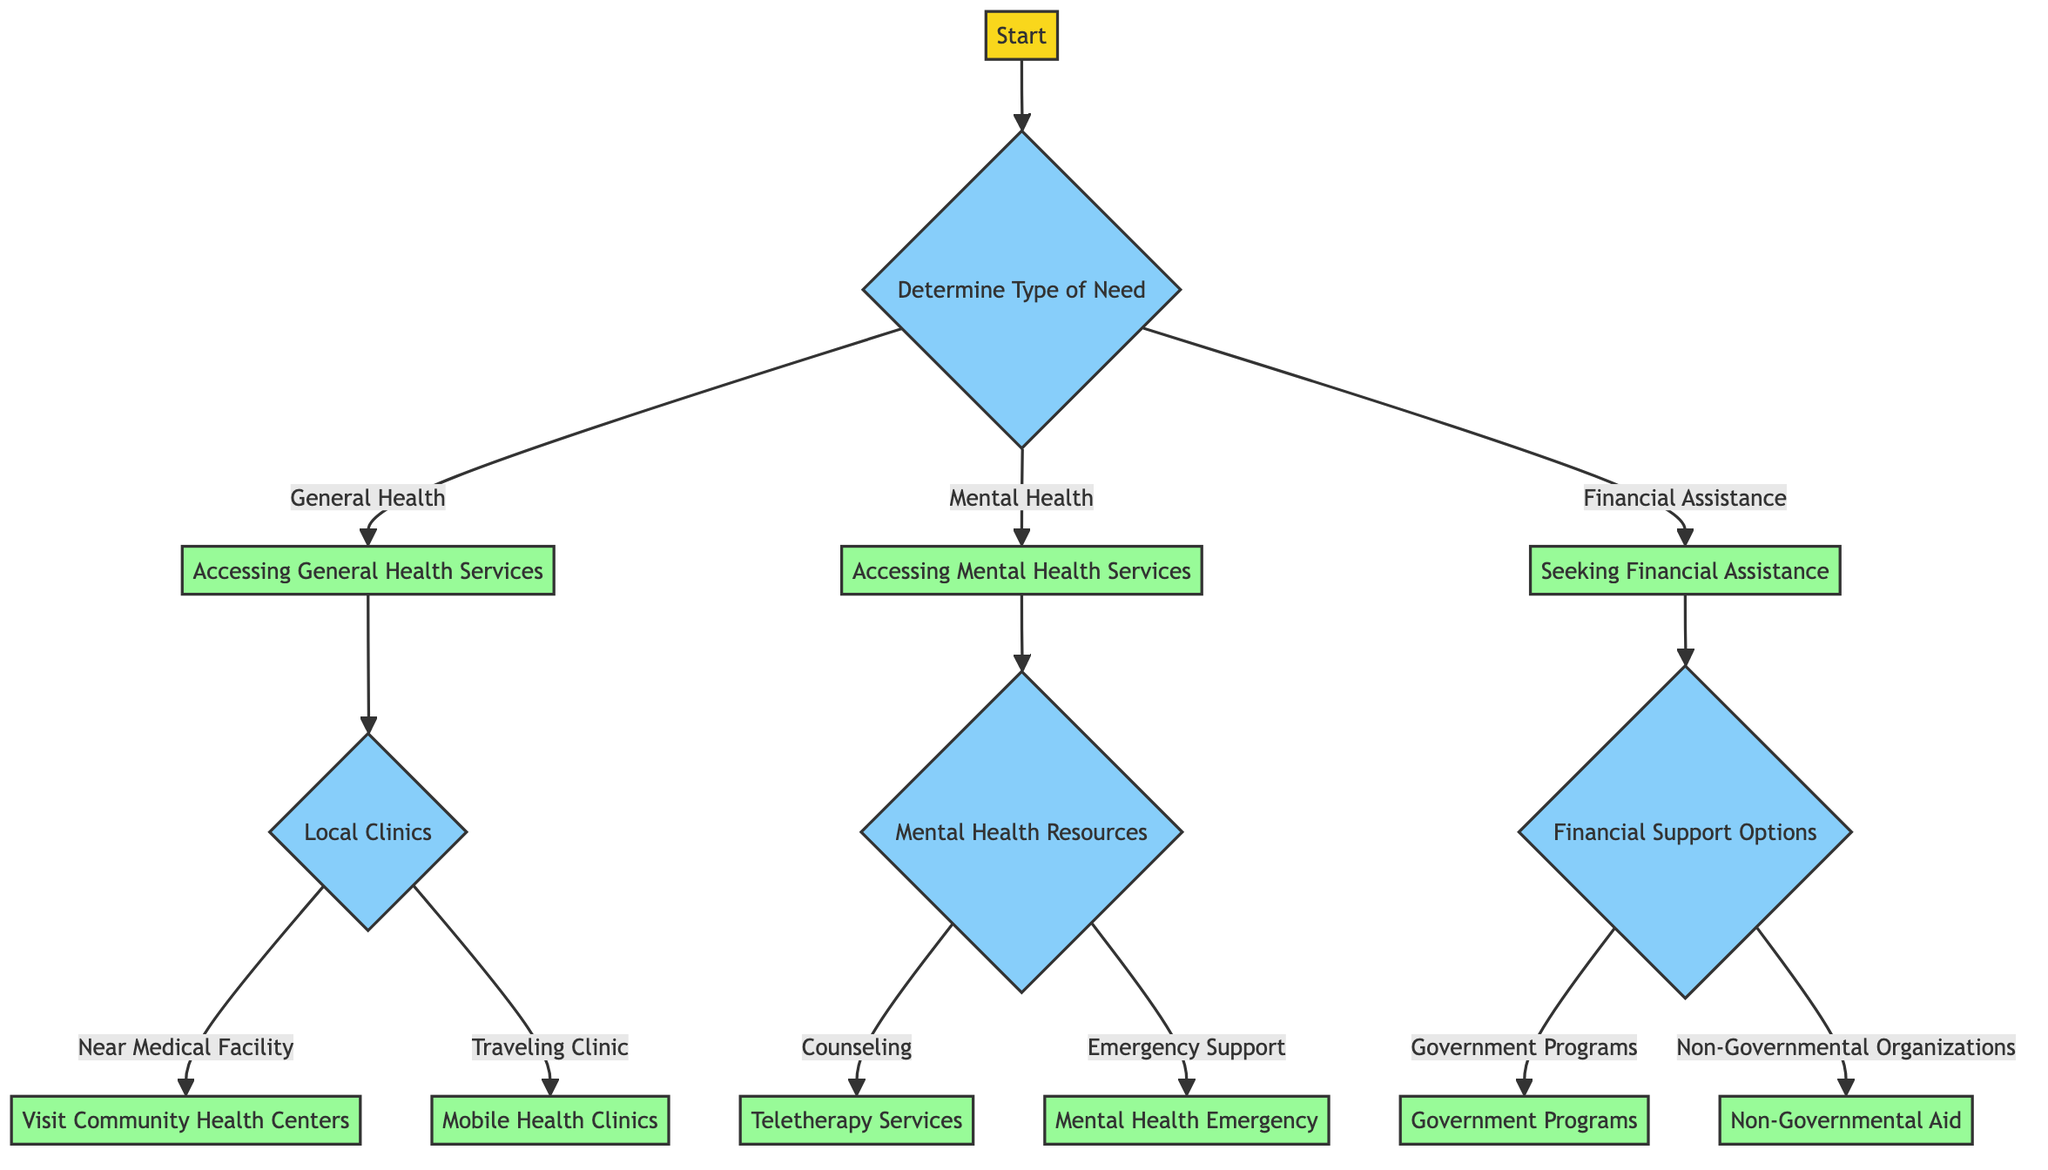What's the first node in the diagram? The first node in the diagram is labeled "Start." It indicates the beginning of the decision tree process.
Answer: Start How many main categories of need are identified in the diagram? The diagram identifies three main categories: General Health, Mental Health, and Financial Assistance. These categories are presented from the second node.
Answer: Three What is the next step after "Accessing General Health Services"? After "Accessing General Health Services," the next step is "Local Clinics," where further decisions are made based on location.
Answer: Local Clinics If a person chooses "Emergency Support," what is the corresponding process they will encounter? If "Emergency Support" is chosen, the corresponding process is "Mental Health Emergency," which instructs contacting the National Suicide Prevention Lifeline.
Answer: Mental Health Emergency What are the two options available under "Financial Support Options"? The two options under "Financial Support Options" are "Government Programs" and "Non-Governmental Organizations." These options help guide individuals toward needed financial resources.
Answer: Government Programs and Non-Governmental Organizations Which node comes after indicating "Near Medical Facility"? The node that comes after indicating "Near Medical Facility" is "Visit Community Health Centers," which suggests finding local health centers.
Answer: Visit Community Health Centers How can one access teletherapy services according to the diagram? According to the diagram, one can access teletherapy services by using platforms like BetterHelp or Talkspace. This represents a digital approach to mental health support.
Answer: Use platforms like BetterHelp or Talkspace Which action should be taken if a person needs "Counseling"? If a person needs "Counseling," they should choose "Teletherapy Services," which provides a means to receive counseling remotely.
Answer: Teletherapy Services What should someone do if they are seeking financial assistance through government programs? If seeking financial assistance through government programs, the action to take is to apply for Medicaid or SNAP benefits, which are specific governmental resources provided.
Answer: Apply for Medicaid or SNAP benefits 